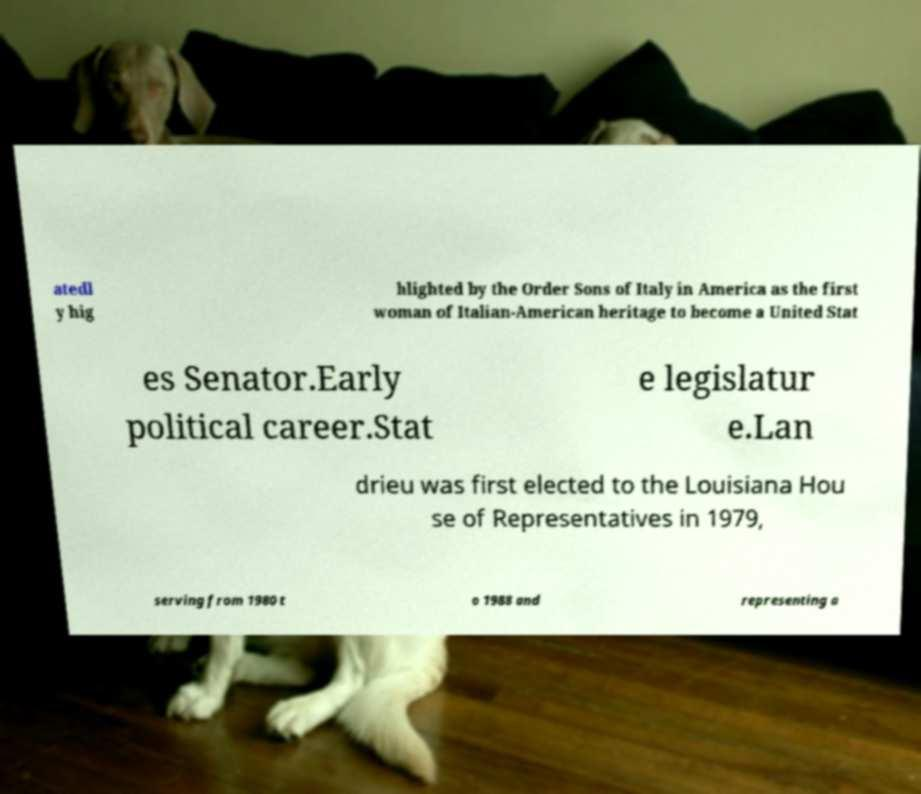What messages or text are displayed in this image? I need them in a readable, typed format. atedl y hig hlighted by the Order Sons of Italy in America as the first woman of Italian-American heritage to become a United Stat es Senator.Early political career.Stat e legislatur e.Lan drieu was first elected to the Louisiana Hou se of Representatives in 1979, serving from 1980 t o 1988 and representing a 